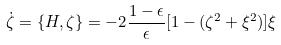Convert formula to latex. <formula><loc_0><loc_0><loc_500><loc_500>\dot { \zeta } = \{ H , \zeta \} = - 2 \frac { 1 - \epsilon } { \epsilon } [ 1 - ( \zeta ^ { 2 } + \xi ^ { 2 } ) ] \xi</formula> 